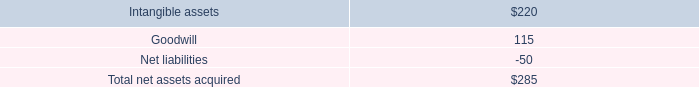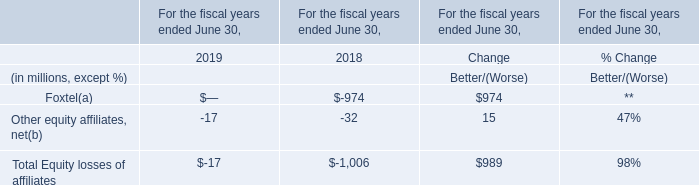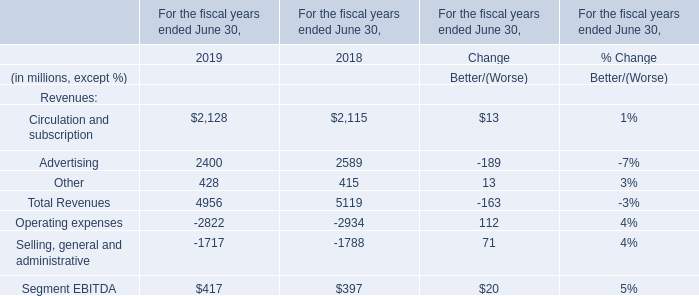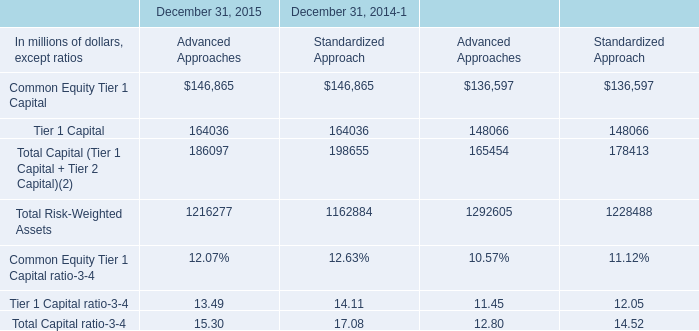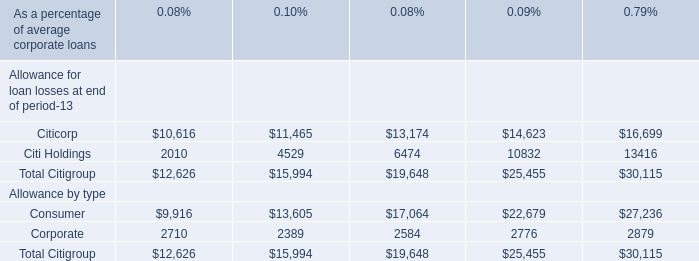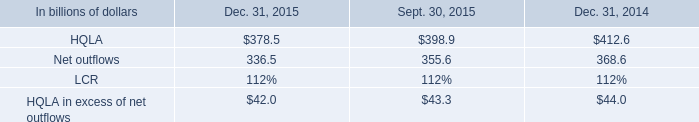What is the growing rate of Other equity affiliates, net in Table 1 in the year with the most Other in Table 2? 
Computations: ((428 - 415) / 415)
Answer: 0.03133. 